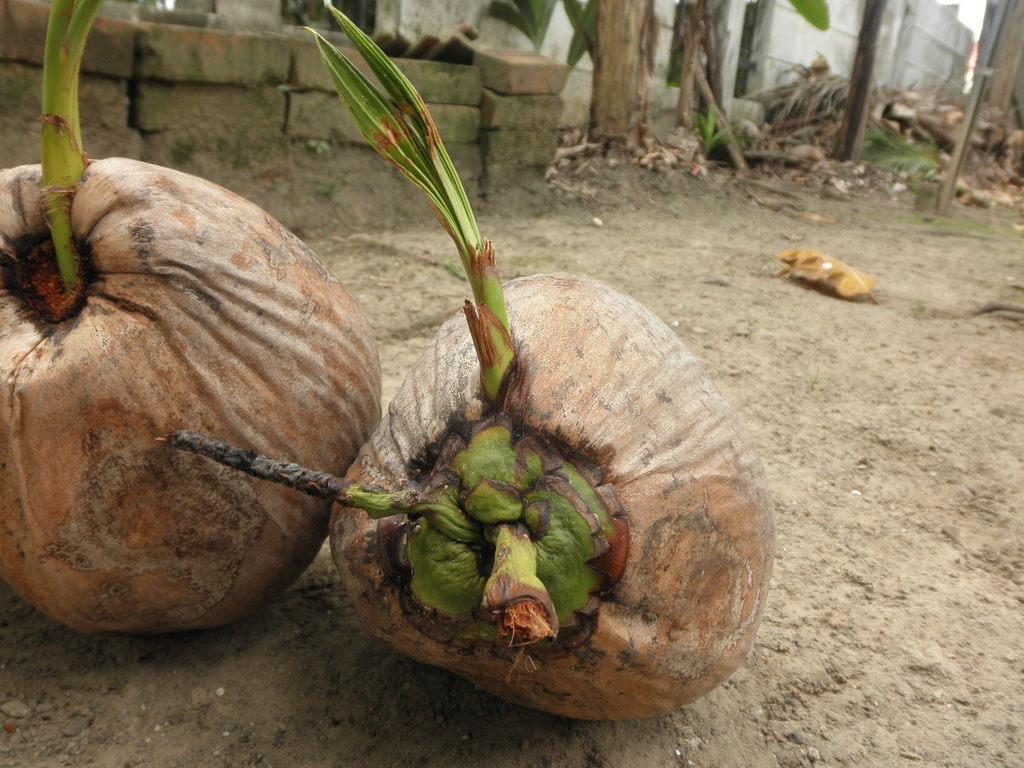What type of fruit is present in the image? There are coconuts in the image. What can be seen in the background of the image? There are bricks and trees in the background of the image. How many teeth can be seen in the image? There are no teeth visible in the image. What type of cattle is present in the image? There are no cattle present in the image. 